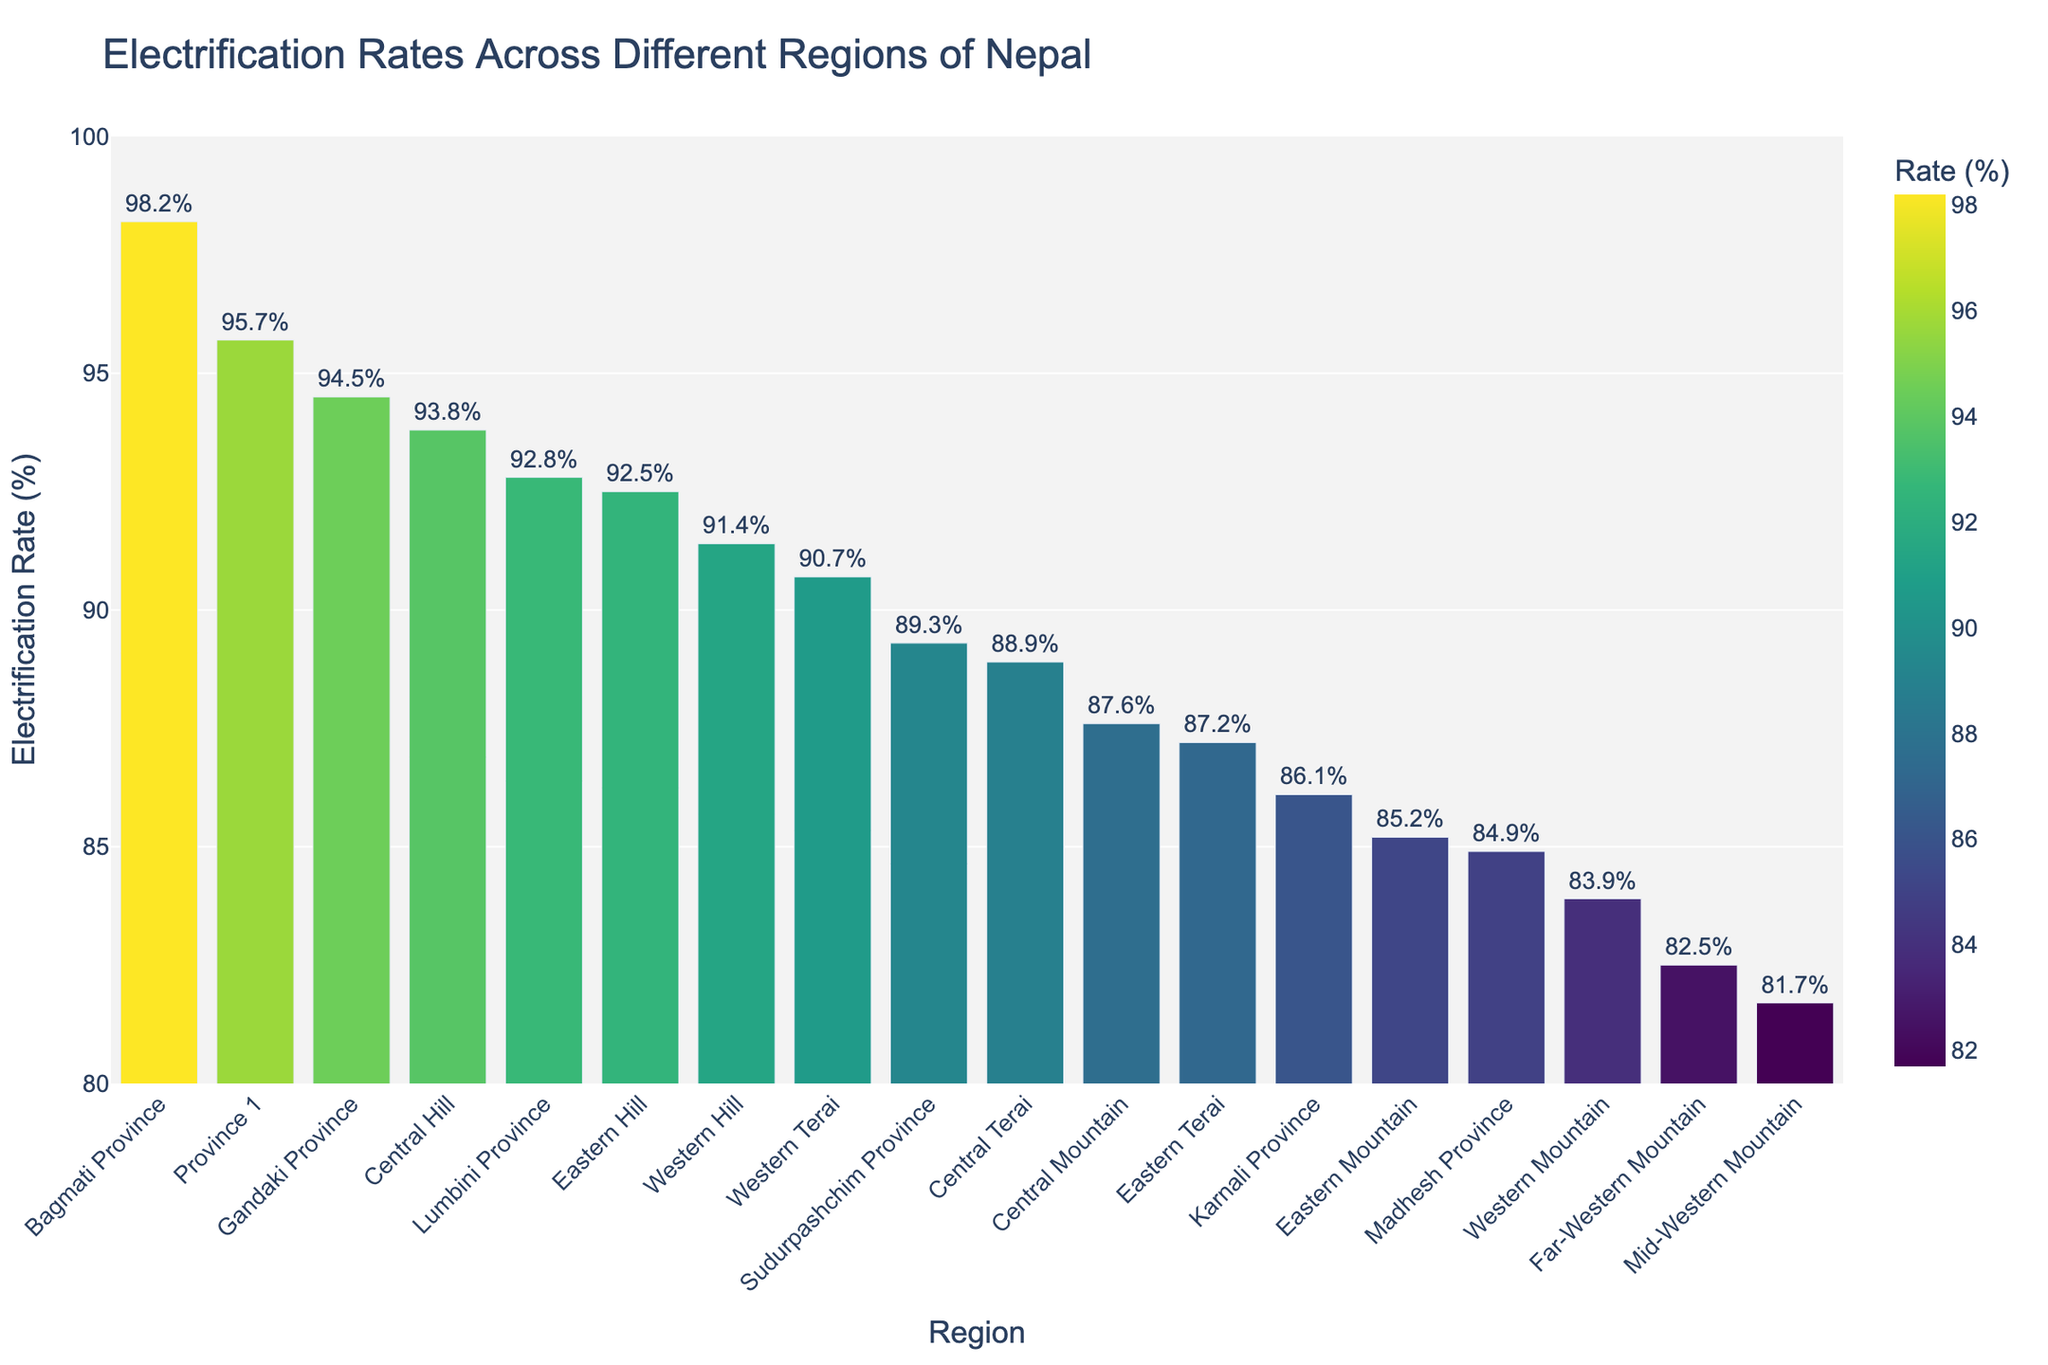What's the region with the highest electrification rate? The bar chart shows the regions of Nepal and their electrification rates. The tallest bar, representing the highest rate, belongs to Bagmati Province.
Answer: Bagmati Province How many regions have an electrification rate above 90%? To answer this, count the number of bars in the chart that extend above the 90% mark on the y-axis. Bagmati Province, Province 1, Gandaki Province, Lumbini Province, Central Hill, Eastern Hill, and Western Terai are the regions with rates above 90%.
Answer: 7 What's the difference in electrification rate between Bagmati Province and Madhesh Province? Bagmati Province has an electrification rate of 98.2%, and Madhesh Province has 84.9%. Subtract the latter from the former to find the difference: 98.2 - 84.9.
Answer: 13.3% Which region has the lowest electrification rate, and what is it? By identifying the shortest bar in the chart, we can see that Mid-Western Mountain has the lowest electrification rate. The corresponding rate can be read directly from the chart.
Answer: Mid-Western Mountain, 81.7% Is the electrification rate of Karnali Province higher or lower than the electrification rate of Central Hill? By comparing the heights of the bars for Karnali Province and Central Hill, it is evident that Central Hill has a higher electrification rate than Karnali Province.
Answer: Lower What is the average electrification rate of the top three regions? The top three regions are Bagmati Province (98.2%), Province 1 (95.7%), and Gandaki Province (94.5%). Calculate the average by summing these rates and dividing by three: (98.2 + 95.7 + 94.5) / 3.
Answer: 96.13% Among the regions with an electrification rate lower than 85%, which one has the highest rate? To solve this, identify all regions with rates below 85%. Those regions are Madhesh Province (84.9%), Far-Western Mountain (82.5%), and Mid-Western Mountain (81.7%). Madhesh Province has the highest rate among them.
Answer: Madhesh Province What percentage of the regions have an electrification rate below 90%? Count the total number of regions (18) and those with electrification rates below 90% (Karnali Province, Madhesh Province, Far-Western Mountain, Mid-Western Mountain, Western Mountain, Eastern Mountain, Central Mountain, Western Hill, Central Terai, and Eastern Terai: 10 regions). Divide the number below 90% by the total and multiply by 100: (10/18) x 100.
Answer: 55.56% What is the combined electrification rate of Sudurpashchim Province and Western Hill? Add the electrification rates of Sudurpashchim Province (89.3%) and Western Hill (91.4%).
Answer: 180.7% Which has a higher electrification rate, the average of Eastern Mountain, Central Mountain, and Western Mountain or the average of Western Terai, Central Terai, and Eastern Terai? First, find the average electrification rate of Eastern Mountain (85.2%), Central Mountain (87.6%), and Western Mountain (83.9%): (85.2 + 87.6 + 83.9) / 3 = 85.57%. Then find the average for Western Terai (90.7%), Central Terai (88.9%), and Eastern Terai (87.2%): (90.7 + 88.9 + 87.2) / 3 = 88.93%. Compare the two averages.
Answer: Western Terai, Central Terai, and Eastern Terai 